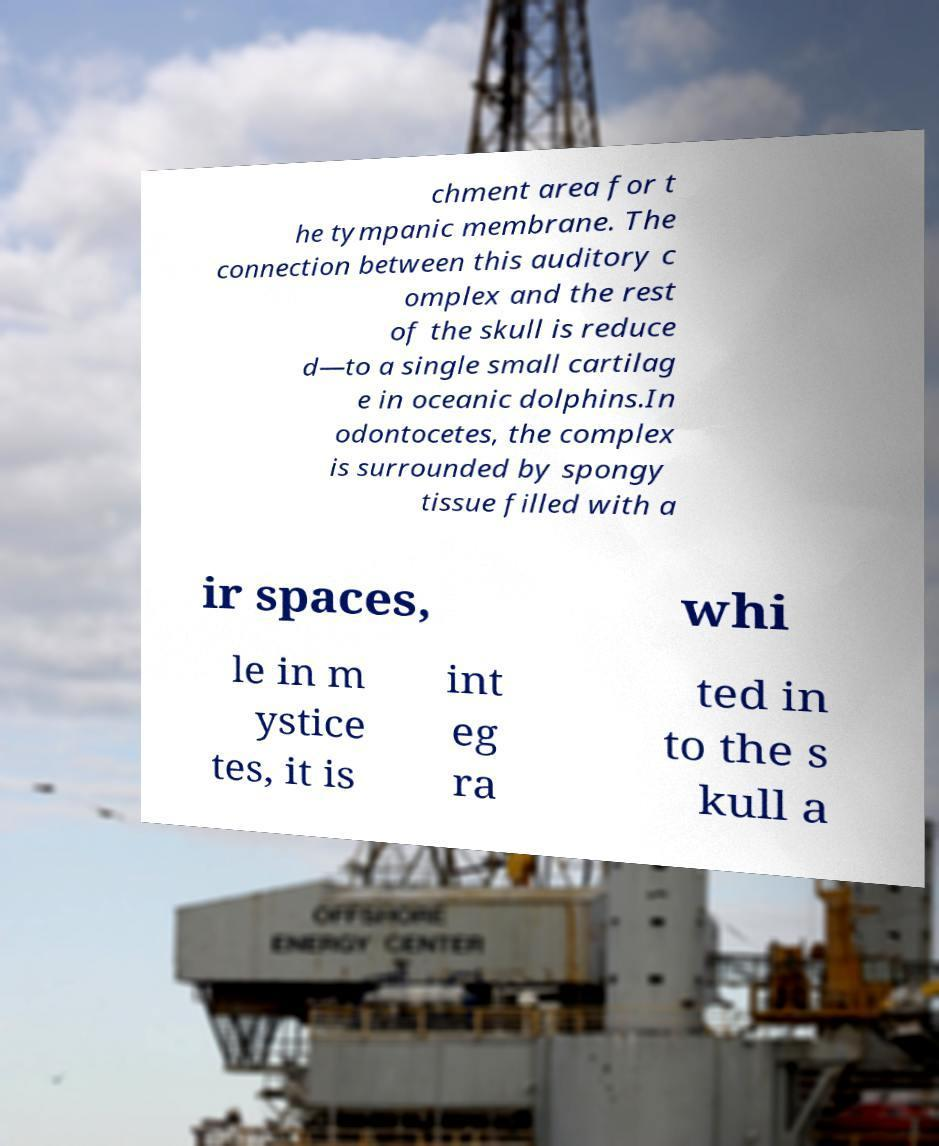What messages or text are displayed in this image? I need them in a readable, typed format. chment area for t he tympanic membrane. The connection between this auditory c omplex and the rest of the skull is reduce d—to a single small cartilag e in oceanic dolphins.In odontocetes, the complex is surrounded by spongy tissue filled with a ir spaces, whi le in m ystice tes, it is int eg ra ted in to the s kull a 